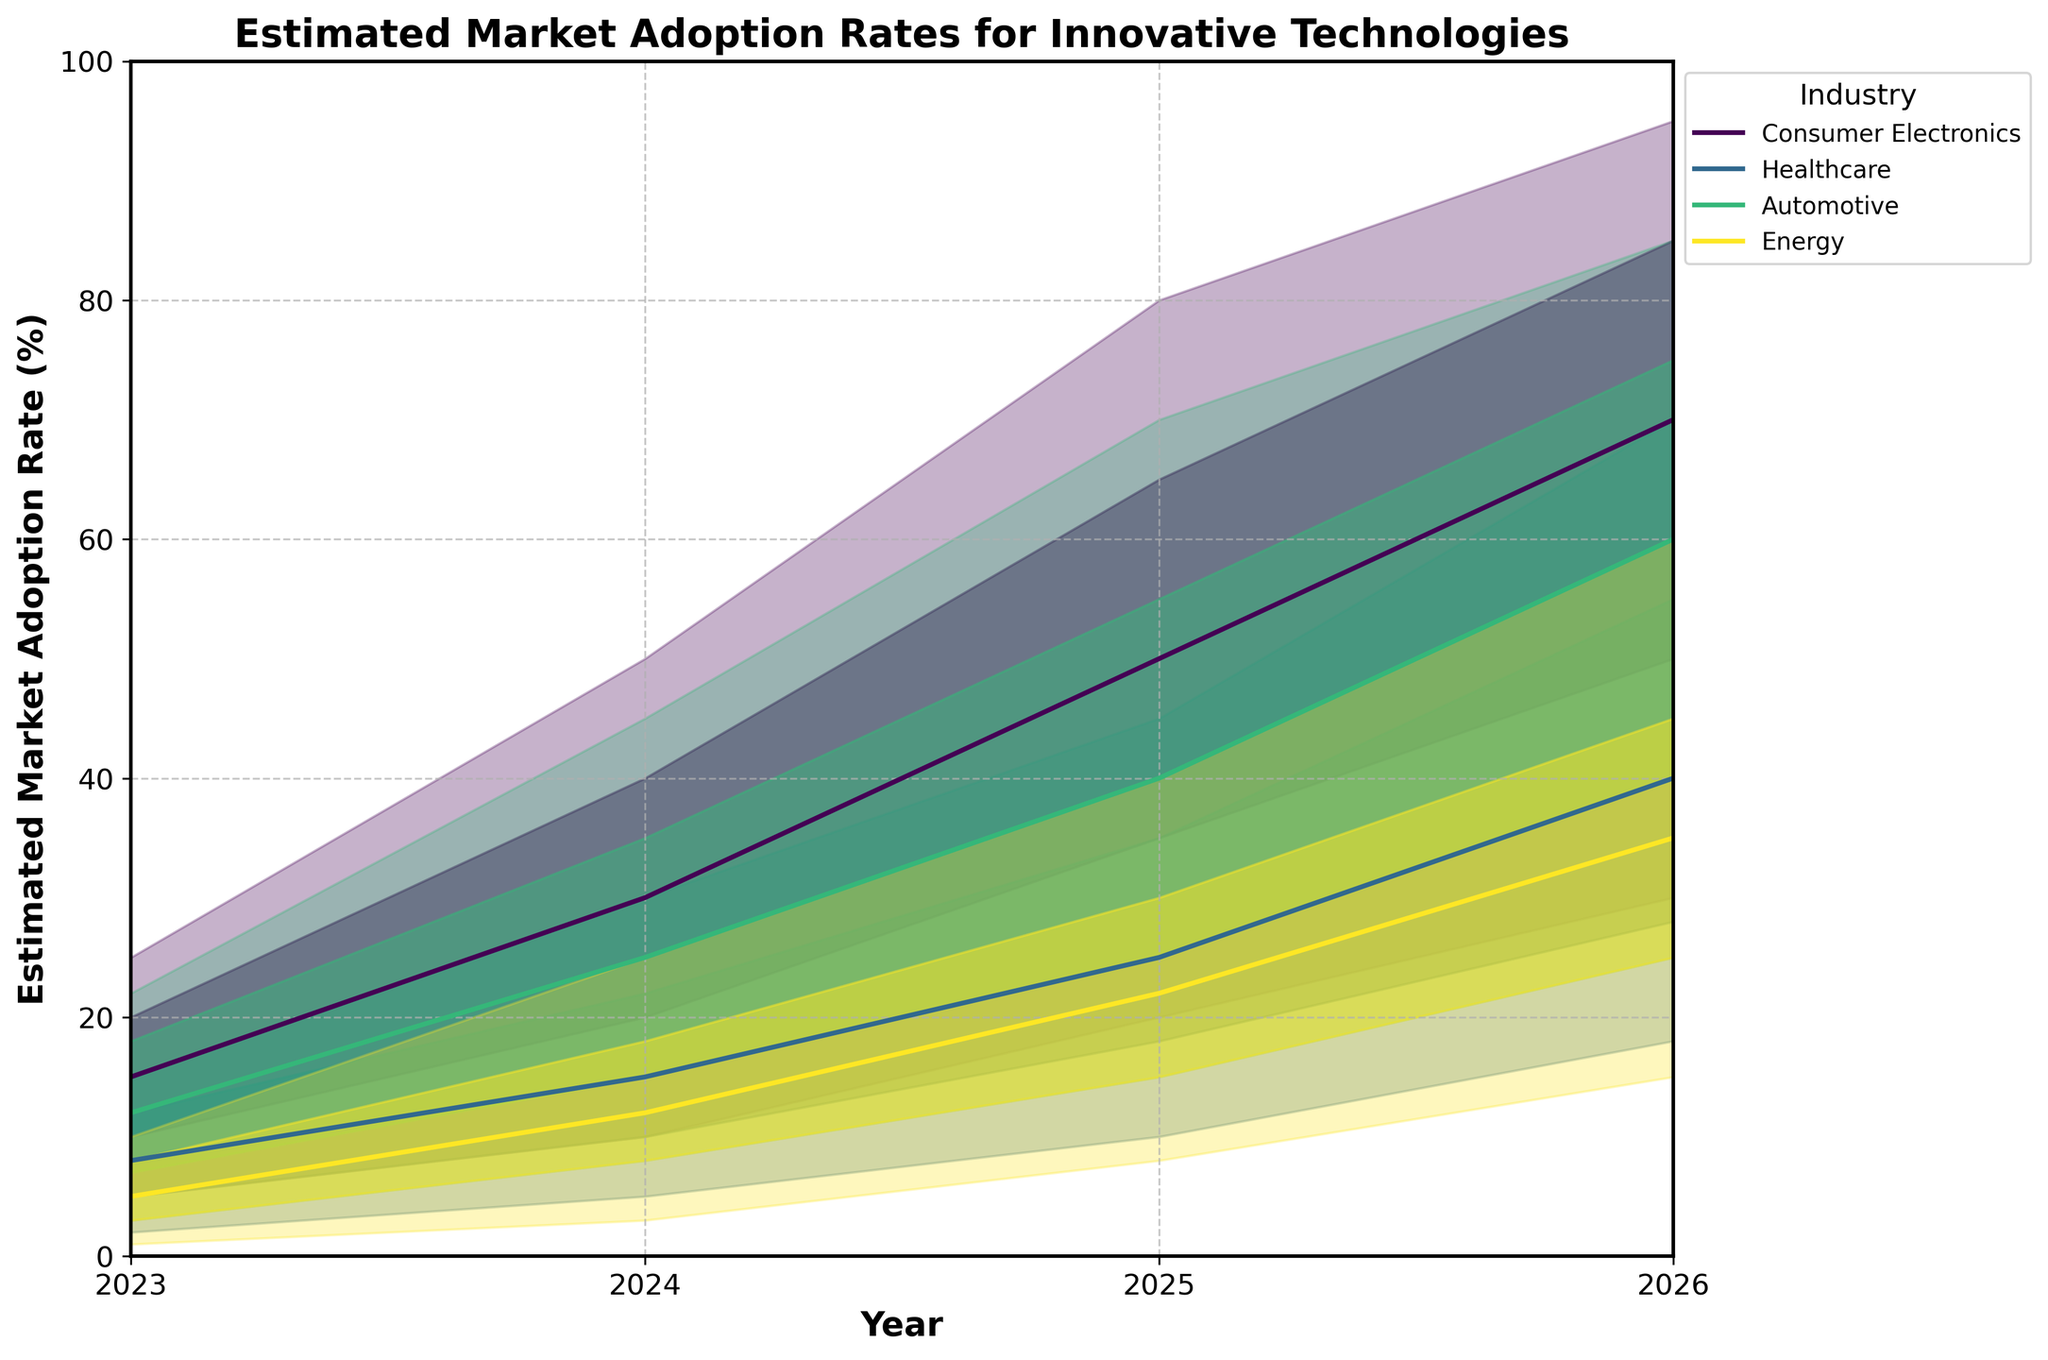What's the title of the chart? The title of the chart is found at the top of the figure. It reads "Estimated Market Adoption Rates for Innovative Technologies".
Answer: Estimated Market Adoption Rates for Innovative Technologies Which industry has the highest estimated market adoption rate in 2026 at the "Mid" level? In 2026, we look at the midpoint (Mid) values for all industries. The "Mid" value for Consumer Electronics is 70%, for Healthcare is 40%, for Automotive is 60%, and for Energy is 35%. Consumer Electronics has the highest at 70%.
Answer: Consumer Electronics How does the estimated market adoption rate for Healthcare in 2026 at the "High" level compare to Energy in the same year? We consider the high values in 2026 for both Healthcare and Energy. Healthcare is at 70%, and Energy is at 60%. Comparing the two, Healthcare's estimated adoption rate is higher.
Answer: Healthcare is higher What is the range of estimated market adoption rates for Automotive in 2024? The range is calculated by subtracting the lowest estimate (Low) from the highest estimate (High) for Automotive in 2024. That is 45% (High) - 8% (Low) = 37%.
Answer: 37% On average, how much does the "Mid" estimated market adoption rate for Consumer Electronics increase each year? We need to calculate the average increase per year for the "Mid" values of Consumer Electronics. From 2023 to 2024, the increase is 30-15=15. From 2024 to 2025, it's 50-30=20. From 2025 to 2026, it's 70-50=20. The total increase over 3 years is 15+20+20=55, so the average yearly increase is 55/3 ≈ 18.33%.
Answer: 18.33% Which industry shows the most significant improvement in the "Low-Mid" adoption rates from 2023 to 2026? We calculate the difference between the 2026 "Low-Mid" rates and 2023 "Low-Mid" rates for each industry. Consumer Electronics: 50-10=40, Healthcare: 28-5=23, Automotive: 40-7=33, Energy: 25-3=22. Consumer Electronics shows the most significant improvement with a 40 percentage point increase.
Answer: Consumer Electronics What are the estimated market adoption rates for Energy in 2025 at all prediction levels? We examine the values for Energy in 2025 across all levels: Low: 8%, Low-Mid: 15%, Mid: 22%, Mid-High: 30%, High: 40%.
Answer: 8%, 15%, 22%, 30%, 40% Explain how the fan chart visually communicates uncertainty in market adoption rates. The fan chart uses different shaded regions to represent varying levels of certainty. The wider the fan, the greater the uncertainty. The central line (Mid) provides the median estimate, while the Low and High boundaries show the most conservative and most optimistic estimates respectively.
Answer: Shaded regions represent certainty levels; wider fan indicates greater uncertainty; Mid line gives the median estimate What is the difference between the Mid-High and Low-Mid adoption rates for healthcare in 2025? To find the difference, we subtract the Low-Mid value from the Mid-High value for healthcare in 2025. That is 35-18=17%.
Answer: 17% 